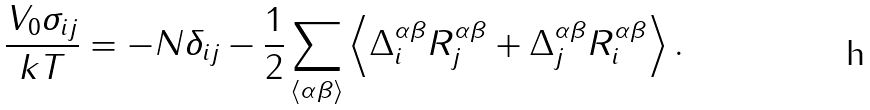<formula> <loc_0><loc_0><loc_500><loc_500>\frac { V _ { 0 } \sigma _ { i j } } { k T } = - N \delta _ { i j } - \frac { 1 } { 2 } \sum _ { \langle \alpha \beta \rangle } \left \langle \Delta _ { i } ^ { \alpha \beta } R ^ { \alpha \beta } _ { j } + \Delta _ { j } ^ { \alpha \beta } R ^ { \alpha \beta } _ { i } \right \rangle .</formula> 